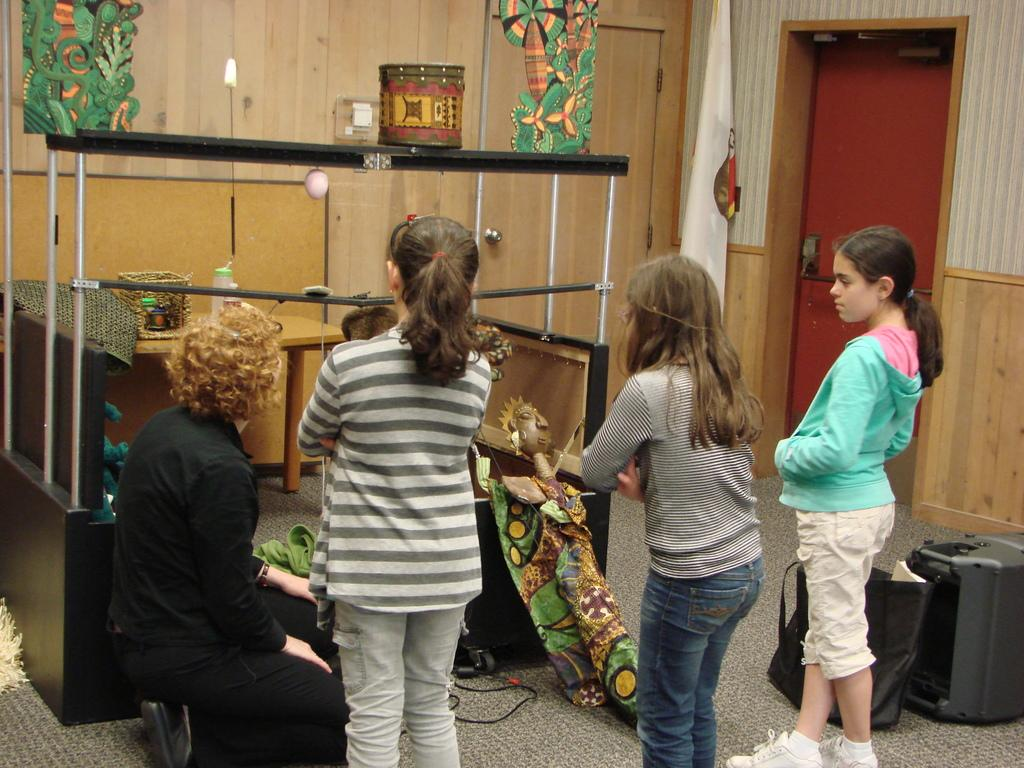What is located in the foreground of the image? There are people in the foreground of the image. What is in front of the people in the image? There are puppets in front of the people. What can be seen in the background of the image? There are doors, suitcases, and other objects in the background of the image. What rule is being enforced by the father in the image? There is no father present in the image, and no rule is being enforced. What type of paint is being used to decorate the puppets in the image? There is no paint or indication of painting on the puppets in the image. 